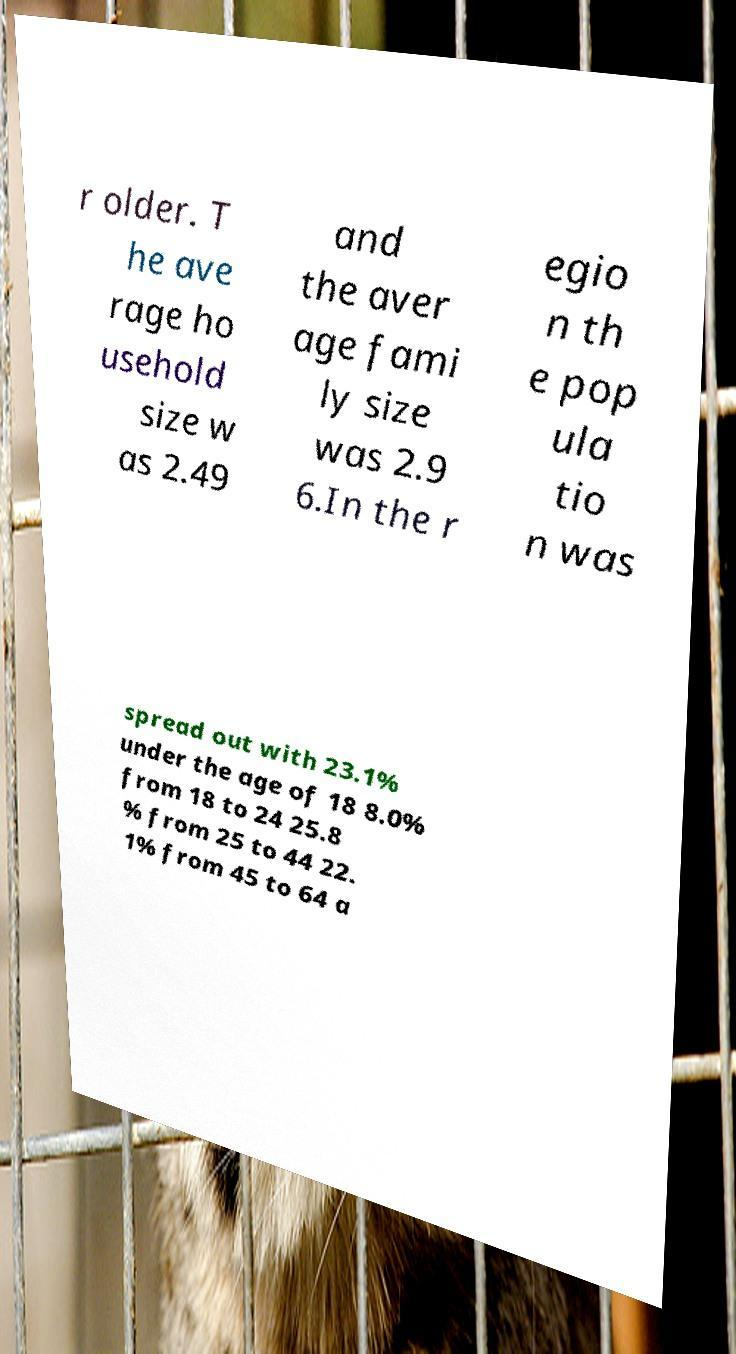Can you accurately transcribe the text from the provided image for me? r older. T he ave rage ho usehold size w as 2.49 and the aver age fami ly size was 2.9 6.In the r egio n th e pop ula tio n was spread out with 23.1% under the age of 18 8.0% from 18 to 24 25.8 % from 25 to 44 22. 1% from 45 to 64 a 